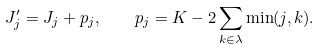Convert formula to latex. <formula><loc_0><loc_0><loc_500><loc_500>J ^ { \prime } _ { j } = J _ { j } + p _ { j } , \quad p _ { j } = K - 2 \sum _ { k \in \lambda } \min ( j , k ) .</formula> 